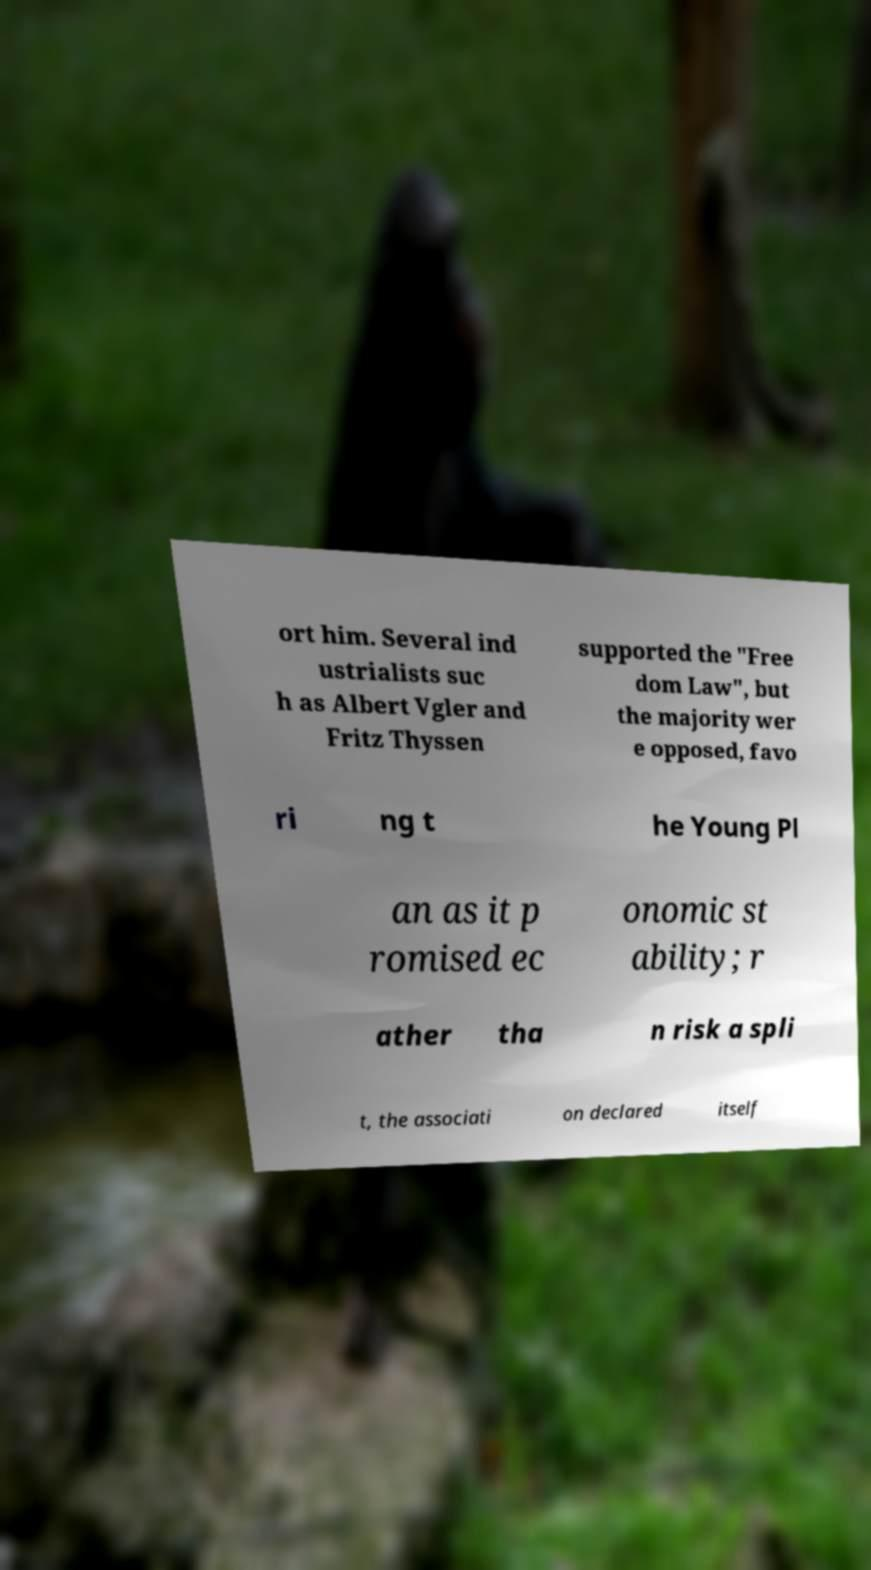Can you read and provide the text displayed in the image?This photo seems to have some interesting text. Can you extract and type it out for me? ort him. Several ind ustrialists suc h as Albert Vgler and Fritz Thyssen supported the "Free dom Law", but the majority wer e opposed, favo ri ng t he Young Pl an as it p romised ec onomic st ability; r ather tha n risk a spli t, the associati on declared itself 